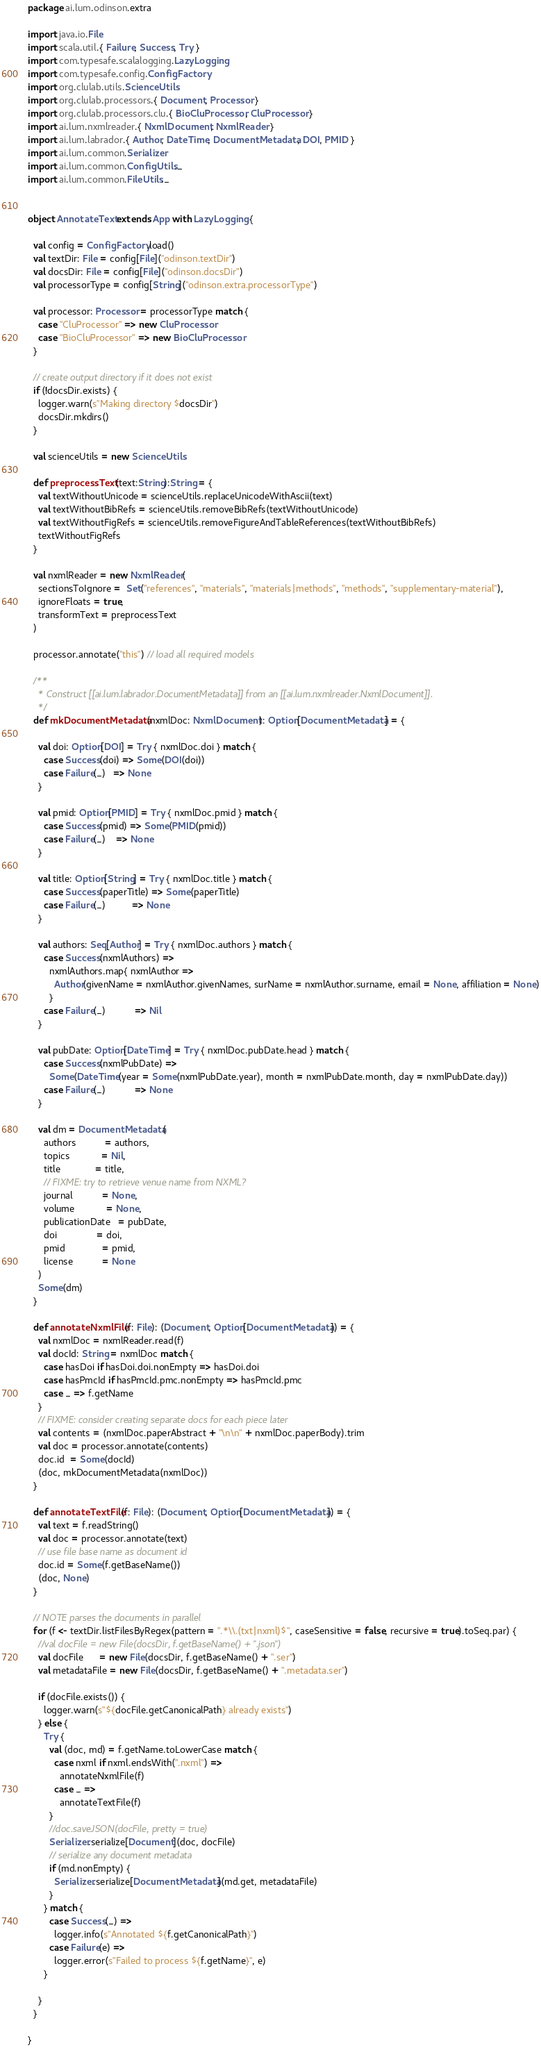<code> <loc_0><loc_0><loc_500><loc_500><_Scala_>package ai.lum.odinson.extra

import java.io.File
import scala.util.{ Failure, Success, Try }
import com.typesafe.scalalogging.LazyLogging
import com.typesafe.config.ConfigFactory
import org.clulab.utils.ScienceUtils
import org.clulab.processors.{ Document, Processor }
import org.clulab.processors.clu.{ BioCluProcessor, CluProcessor }
import ai.lum.nxmlreader.{ NxmlDocument, NxmlReader }
import ai.lum.labrador.{ Author, DateTime, DocumentMetadata, DOI, PMID }
import ai.lum.common.Serializer
import ai.lum.common.ConfigUtils._
import ai.lum.common.FileUtils._


object AnnotateText extends App with LazyLogging {

  val config = ConfigFactory.load()
  val textDir: File = config[File]("odinson.textDir")
  val docsDir: File = config[File]("odinson.docsDir")
  val processorType = config[String]("odinson.extra.processorType")

  val processor: Processor = processorType match {
    case "CluProcessor" => new CluProcessor
    case "BioCluProcessor" => new BioCluProcessor
  }

  // create output directory if it does not exist
  if (!docsDir.exists) {
    logger.warn(s"Making directory $docsDir")
    docsDir.mkdirs()
  }

  val scienceUtils = new ScienceUtils

  def preprocessText(text:String):String = {
    val textWithoutUnicode = scienceUtils.replaceUnicodeWithAscii(text)
    val textWithoutBibRefs = scienceUtils.removeBibRefs(textWithoutUnicode)
    val textWithoutFigRefs = scienceUtils.removeFigureAndTableReferences(textWithoutBibRefs)
    textWithoutFigRefs
  }

  val nxmlReader = new NxmlReader(
    sectionsToIgnore =  Set("references", "materials", "materials|methods", "methods", "supplementary-material"),
    ignoreFloats = true,
    transformText = preprocessText
  )

  processor.annotate("this") // load all required models

  /**
    * Construct [[ai.lum.labrador.DocumentMetadata]] from an [[ai.lum.nxmlreader.NxmlDocument]].
    */
  def mkDocumentMetadata(nxmlDoc: NxmlDocument): Option[DocumentMetadata] = {

    val doi: Option[DOI] = Try { nxmlDoc.doi } match {
      case Success(doi) => Some(DOI(doi))
      case Failure(_)   => None
    }

    val pmid: Option[PMID] = Try { nxmlDoc.pmid } match {
      case Success(pmid) => Some(PMID(pmid))
      case Failure(_)    => None
    }

    val title: Option[String] = Try { nxmlDoc.title } match {
      case Success(paperTitle) => Some(paperTitle)
      case Failure(_)          => None
    }

    val authors: Seq[Author] = Try { nxmlDoc.authors } match {
      case Success(nxmlAuthors) =>
        nxmlAuthors.map{ nxmlAuthor =>
          Author(givenName = nxmlAuthor.givenNames, surName = nxmlAuthor.surname, email = None, affiliation = None)
        }
      case Failure(_)           => Nil
    }

    val pubDate: Option[DateTime] = Try { nxmlDoc.pubDate.head } match {
      case Success(nxmlPubDate) =>
        Some(DateTime(year = Some(nxmlPubDate.year), month = nxmlPubDate.month, day = nxmlPubDate.day))
      case Failure(_)           => None
    }

    val dm = DocumentMetadata(
      authors           = authors,
      topics            = Nil,
      title             = title,
      // FIXME: try to retrieve venue name from NXML?
      journal           = None,
      volume            = None,
      publicationDate   = pubDate,
      doi               = doi,
      pmid              = pmid,
      license           = None
    )
    Some(dm)
  }

  def annotateNxmlFile(f: File): (Document, Option[DocumentMetadata]) = {
    val nxmlDoc = nxmlReader.read(f)
    val docId: String = nxmlDoc match {
      case hasDoi if hasDoi.doi.nonEmpty => hasDoi.doi
      case hasPmcId if hasPmcId.pmc.nonEmpty => hasPmcId.pmc
      case _ => f.getName
    }
    // FIXME: consider creating separate docs for each piece later
    val contents = (nxmlDoc.paperAbstract + "\n\n" + nxmlDoc.paperBody).trim
    val doc = processor.annotate(contents)
    doc.id  = Some(docId)
    (doc, mkDocumentMetadata(nxmlDoc))
  }

  def annotateTextFile(f: File): (Document, Option[DocumentMetadata]) = {
    val text = f.readString()
    val doc = processor.annotate(text)
    // use file base name as document id
    doc.id = Some(f.getBaseName())
    (doc, None)
  }

  // NOTE parses the documents in parallel
  for (f <- textDir.listFilesByRegex(pattern = ".*\\.(txt|nxml)$", caseSensitive = false, recursive = true).toSeq.par) {
    //val docFile = new File(docsDir, f.getBaseName() + ".json")
    val docFile      = new File(docsDir, f.getBaseName() + ".ser")
    val metadataFile = new File(docsDir, f.getBaseName() + ".metadata.ser")

    if (docFile.exists()) {
      logger.warn(s"${docFile.getCanonicalPath} already exists")
    } else {
      Try {
        val (doc, md) = f.getName.toLowerCase match {
          case nxml if nxml.endsWith(".nxml") =>
            annotateNxmlFile(f)
          case _ =>
            annotateTextFile(f)
        }
        //doc.saveJSON(docFile, pretty = true)
        Serializer.serialize[Document](doc, docFile)
        // serialize any document metadata
        if (md.nonEmpty) {
          Serializer.serialize[DocumentMetadata](md.get, metadataFile)
        }
      } match {
        case Success(_) =>
          logger.info(s"Annotated ${f.getCanonicalPath}")
        case Failure(e) =>
          logger.error(s"Failed to process ${f.getName}", e)
      }

    }
  }

}
</code> 